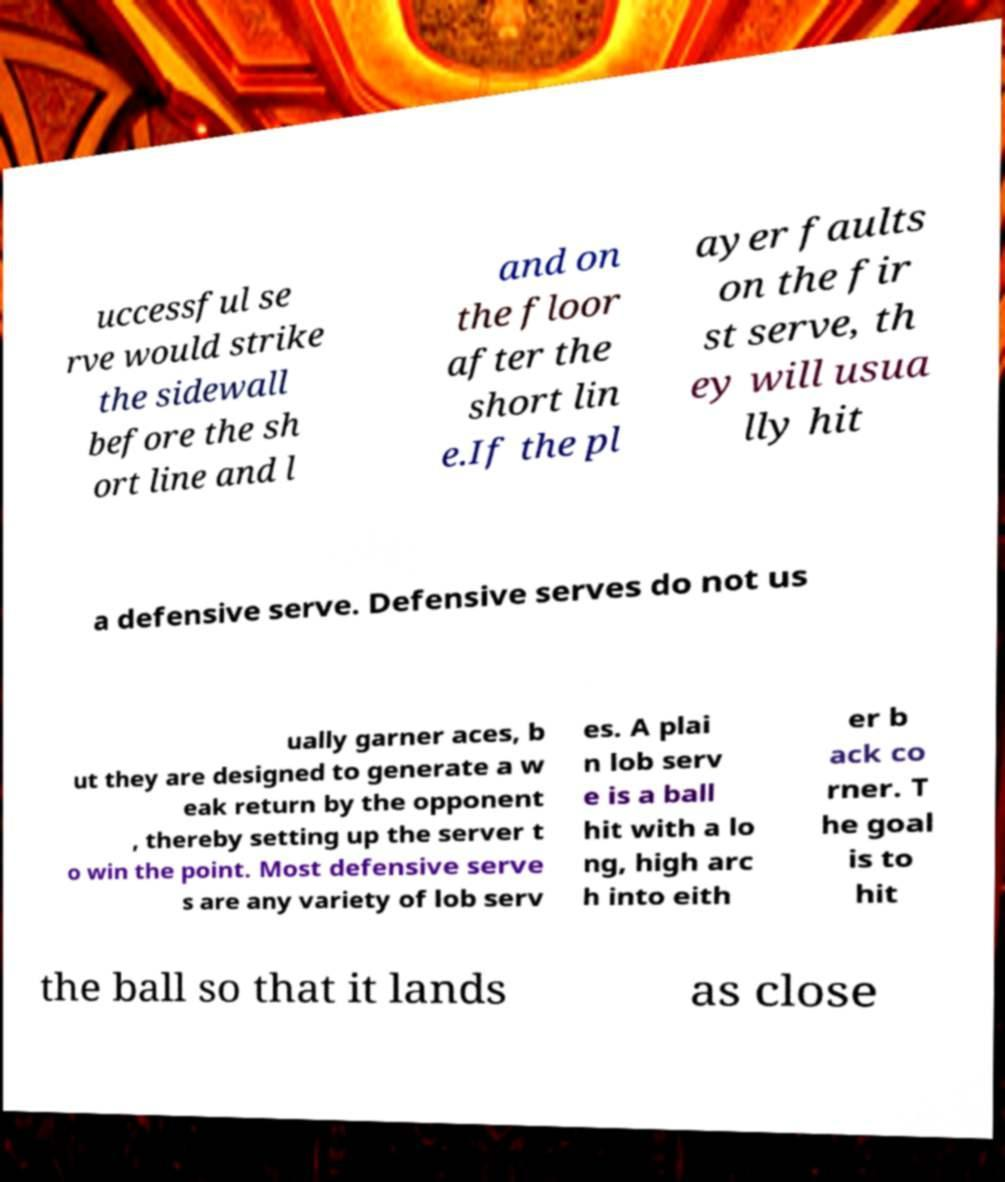Could you assist in decoding the text presented in this image and type it out clearly? uccessful se rve would strike the sidewall before the sh ort line and l and on the floor after the short lin e.If the pl ayer faults on the fir st serve, th ey will usua lly hit a defensive serve. Defensive serves do not us ually garner aces, b ut they are designed to generate a w eak return by the opponent , thereby setting up the server t o win the point. Most defensive serve s are any variety of lob serv es. A plai n lob serv e is a ball hit with a lo ng, high arc h into eith er b ack co rner. T he goal is to hit the ball so that it lands as close 